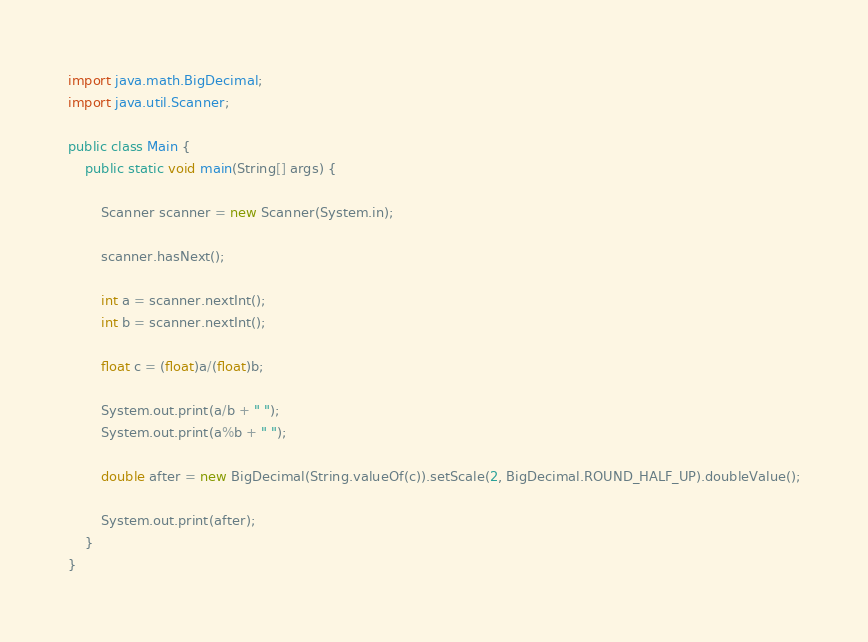Convert code to text. <code><loc_0><loc_0><loc_500><loc_500><_Java_>import java.math.BigDecimal;
import java.util.Scanner;

public class Main {
	public static void main(String[] args) {

		Scanner scanner = new Scanner(System.in);

		scanner.hasNext();

		int a = scanner.nextInt();
		int b = scanner.nextInt();

		float c = (float)a/(float)b;

		System.out.print(a/b + " ");
		System.out.print(a%b + " ");

		double after = new BigDecimal(String.valueOf(c)).setScale(2, BigDecimal.ROUND_HALF_UP).doubleValue();

		System.out.print(after);
	}
}</code> 